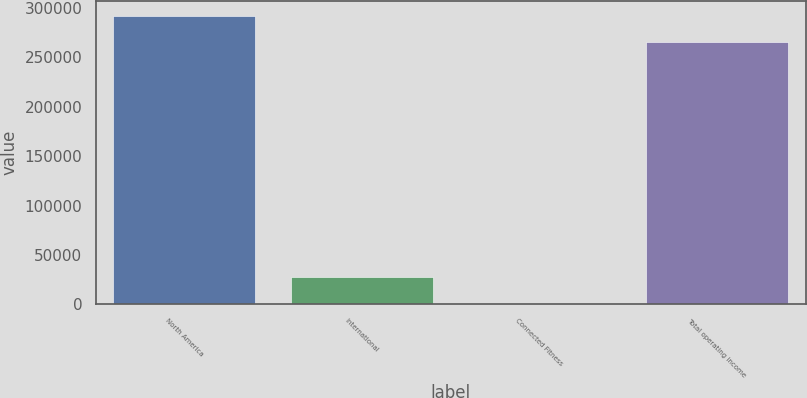<chart> <loc_0><loc_0><loc_500><loc_500><bar_chart><fcel>North America<fcel>International<fcel>Connected Fitness<fcel>Total operating income<nl><fcel>292178<fcel>27614.4<fcel>534<fcel>265098<nl></chart> 